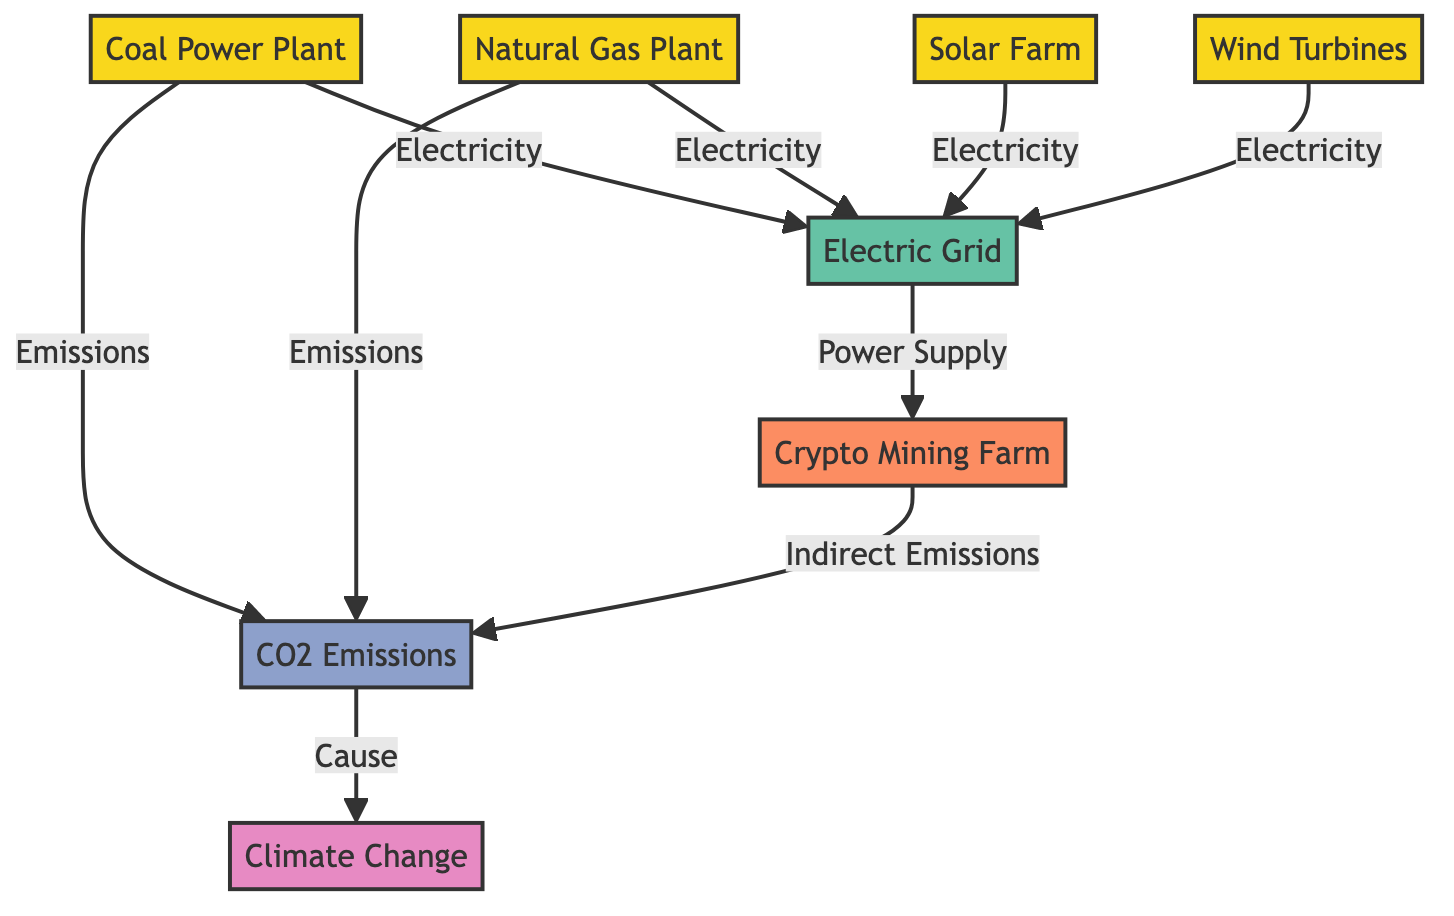What are the types of power plants shown in the diagram? The diagram lists four types of power plants: Coal Power Plant, Natural Gas Plant, Solar Farm, and Wind Turbines. These are direct labeled nodes in the diagram.
Answer: Coal Power Plant, Natural Gas Plant, Solar Farm, Wind Turbines What flows from the Electric Grid to the Crypto Mining Farm? The flow from the Electric Grid to the Crypto Mining Farm is labeled as "Power Supply," indicating the energy provided for mining activities.
Answer: Power Supply How many types of emissions are connected to the CO2 Emissions node? There are three sources connected to the CO2 Emissions node: Coal Power Plant, Natural Gas Plant, and Crypto Mining Farm. By counting the connections to CO2 Emissions, we get three distinct sources.
Answer: 3 Which power plant has the most significant environmental impact according to the diagram? The Coal Power Plant is linked to CO2 Emissions but also indirectly influences through the Crypto Mining Farm. It indicates a significant environmental impact because coal is known for high emissions.
Answer: Coal Power Plant What is the final consequence of CO2 Emissions in the diagram? The diagram shows that CO2 Emissions lead to Climate Change, illustrating a direct cause-effect relationship from emissions to the larger issue of climate impact.
Answer: Climate Change Which two power plants produce indirect emissions? The Natural Gas Plant and the Crypto Mining Farm lead to CO2 Emissions. However, since the question asks for indirect emissions, it can be inferred that only the Crypto Mining Farm emits indirectly contributed emissions compared to the direct emissions from the power plants.
Answer: Crypto Mining Farm What does the Electric Grid connect to? The Electric Grid connects to the Crypto Mining Farm, providing the necessary electricity for its operations. This is a direct connection shown in the diagram.
Answer: Crypto Mining Farm Which node is emphasized as the most significant in this food chain? The Climate Change node is styled with the largest font size, indicating its importance in this food chain as the endpoint or final consequence of the energy consumption flow.
Answer: Climate Change How many power sources are involved in supplying power to the Electric Grid? The Electric Grid receives power from four sources: Coal Power Plant, Natural Gas Plant, Solar Farm, and Wind Turbines, as shown by the four arrows leading into the Electric Grid.
Answer: 4 